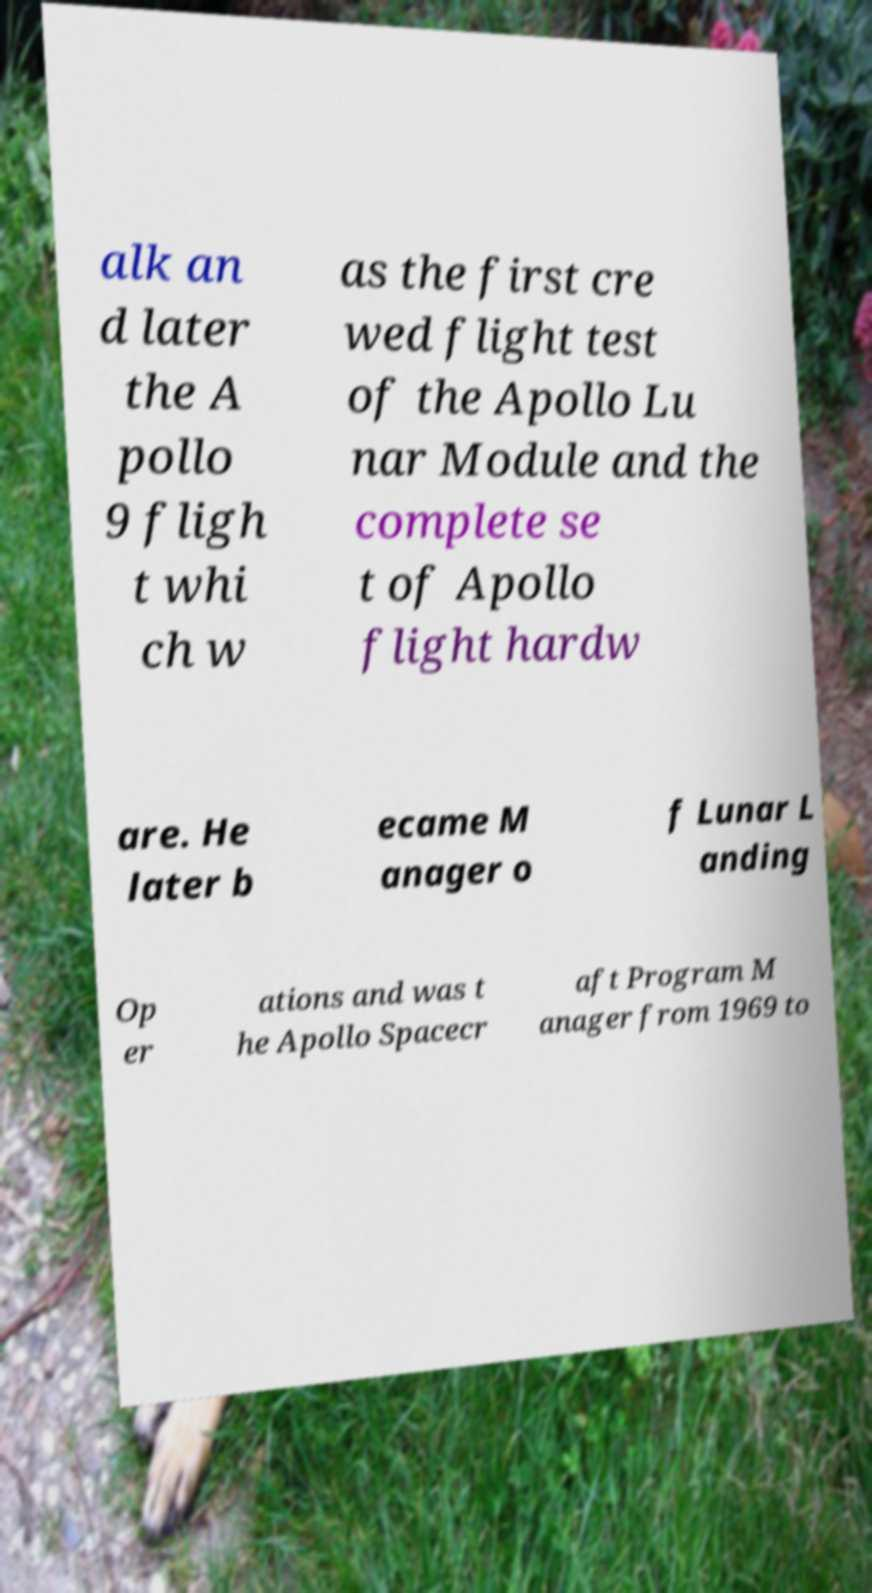Please read and relay the text visible in this image. What does it say? alk an d later the A pollo 9 fligh t whi ch w as the first cre wed flight test of the Apollo Lu nar Module and the complete se t of Apollo flight hardw are. He later b ecame M anager o f Lunar L anding Op er ations and was t he Apollo Spacecr aft Program M anager from 1969 to 